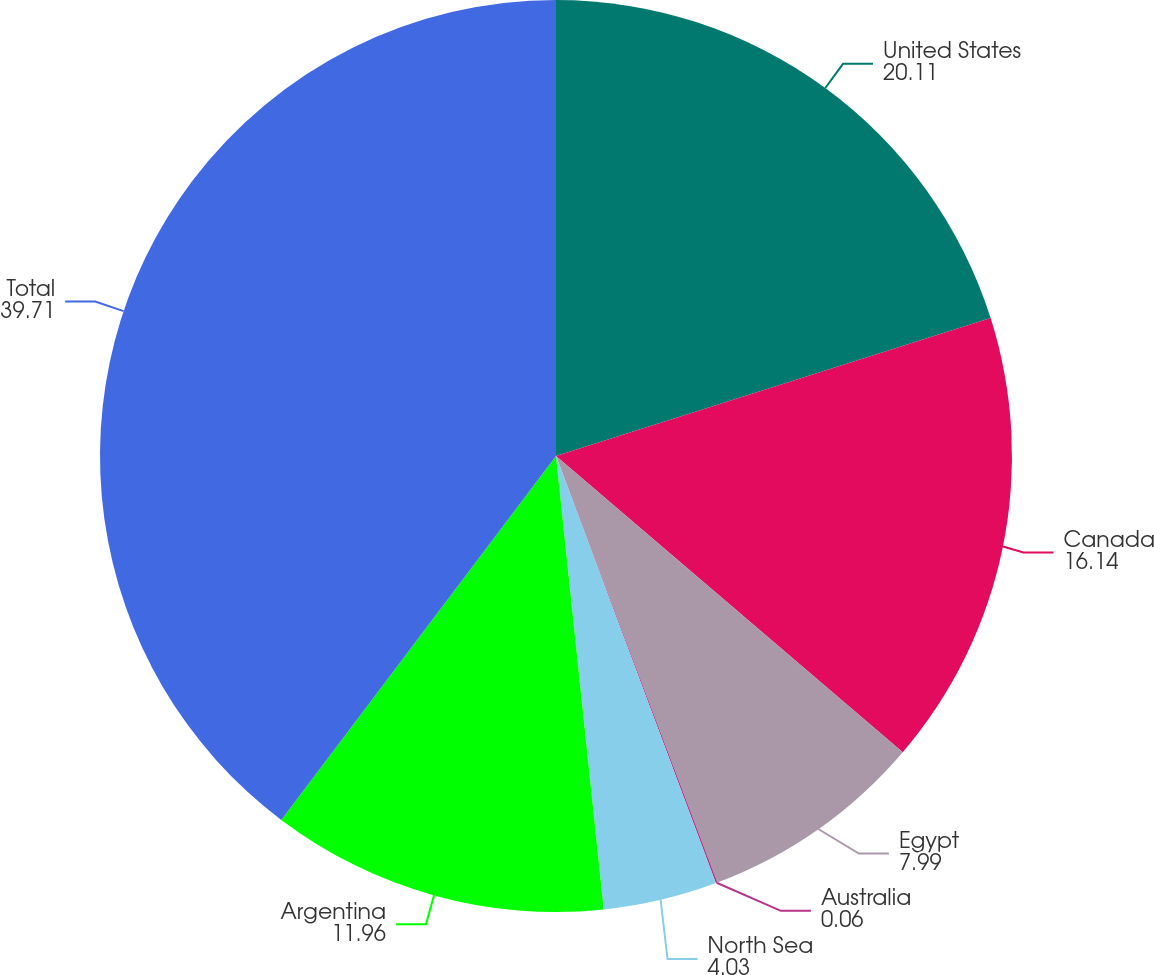Convert chart. <chart><loc_0><loc_0><loc_500><loc_500><pie_chart><fcel>United States<fcel>Canada<fcel>Egypt<fcel>Australia<fcel>North Sea<fcel>Argentina<fcel>Total<nl><fcel>20.11%<fcel>16.14%<fcel>7.99%<fcel>0.06%<fcel>4.03%<fcel>11.96%<fcel>39.71%<nl></chart> 